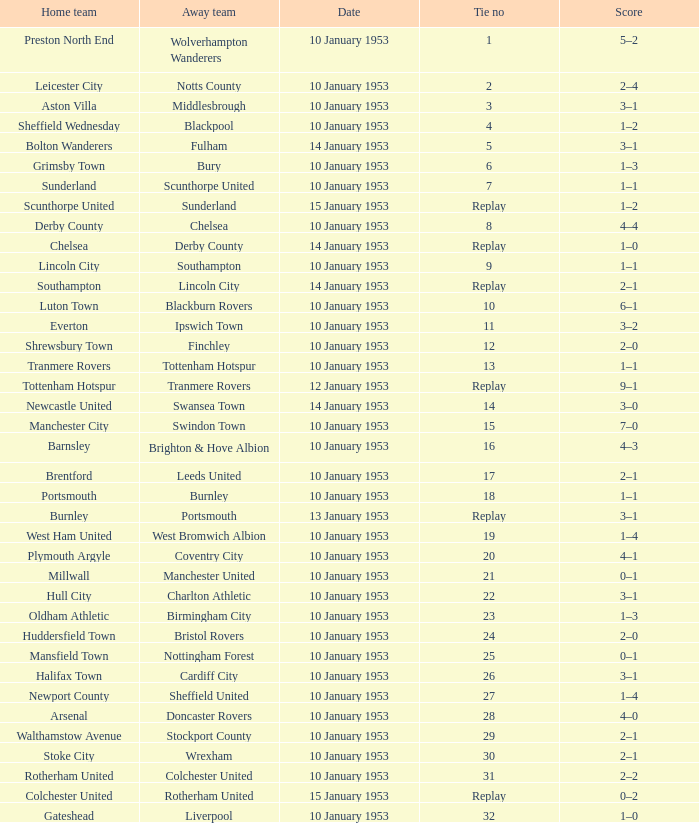What home team has coventry city as the away team? Plymouth Argyle. 